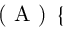Convert formula to latex. <formula><loc_0><loc_0><loc_500><loc_500>( A ) \left \{ \begin{array} { r l } \end{array}</formula> 